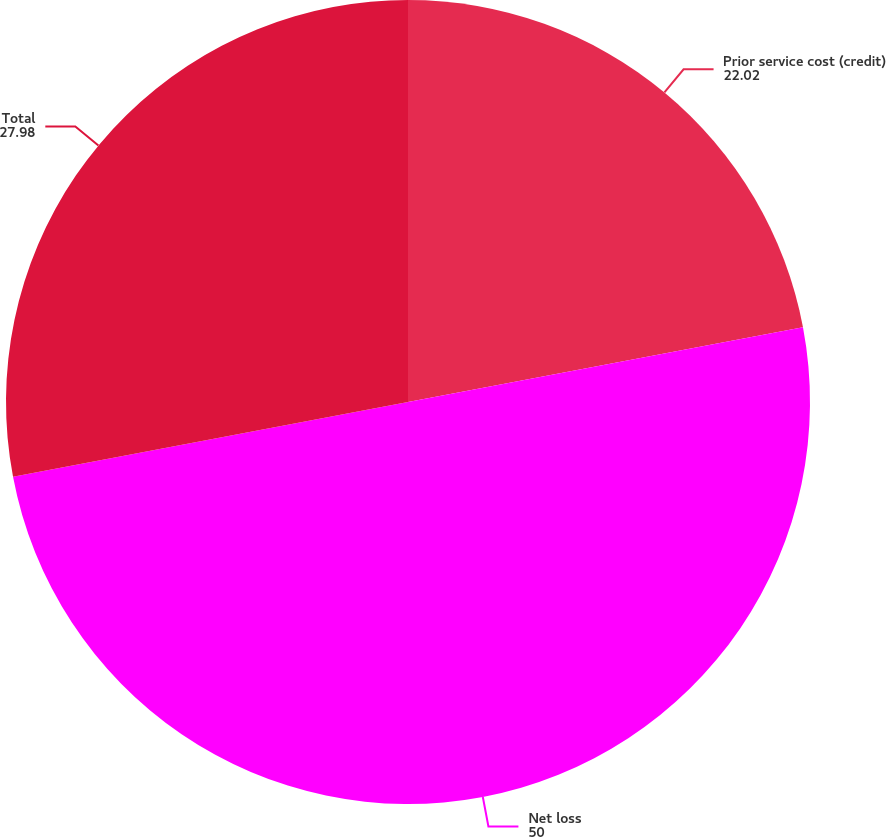<chart> <loc_0><loc_0><loc_500><loc_500><pie_chart><fcel>Prior service cost (credit)<fcel>Net loss<fcel>Total<nl><fcel>22.02%<fcel>50.0%<fcel>27.98%<nl></chart> 